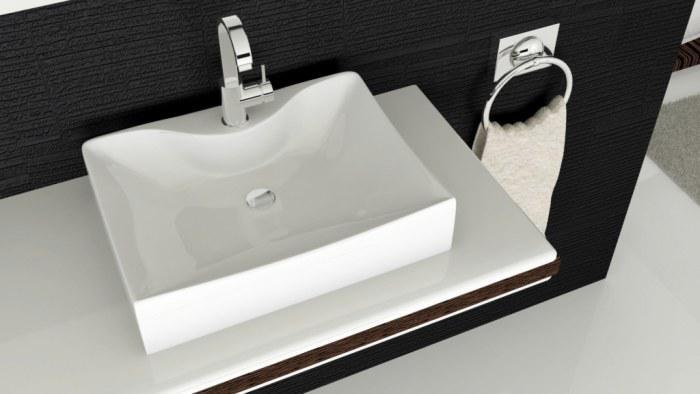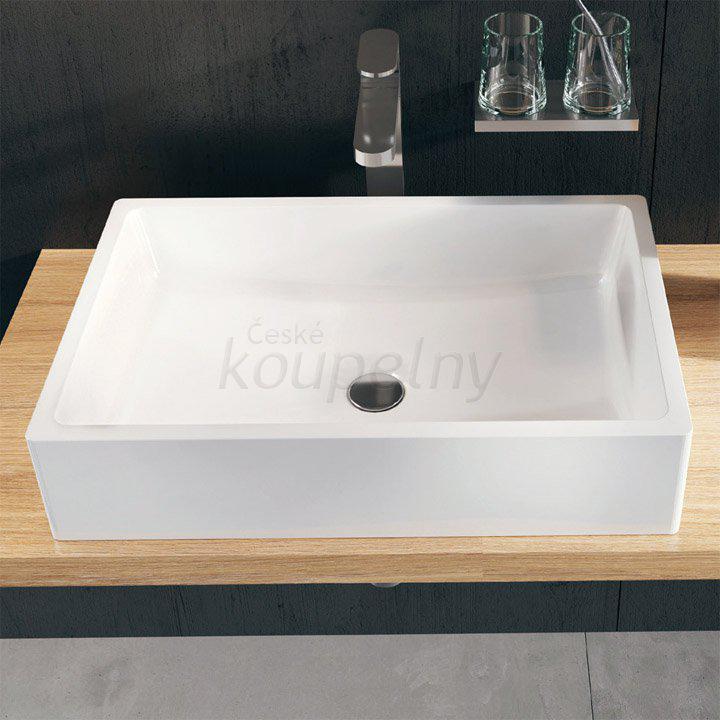The first image is the image on the left, the second image is the image on the right. For the images shown, is this caption "Each of the sinks are attached to a black wall." true? Answer yes or no. Yes. The first image is the image on the left, the second image is the image on the right. For the images displayed, is the sentence "There are two rectangular sinks with faucets attached to counter tops." factually correct? Answer yes or no. Yes. 